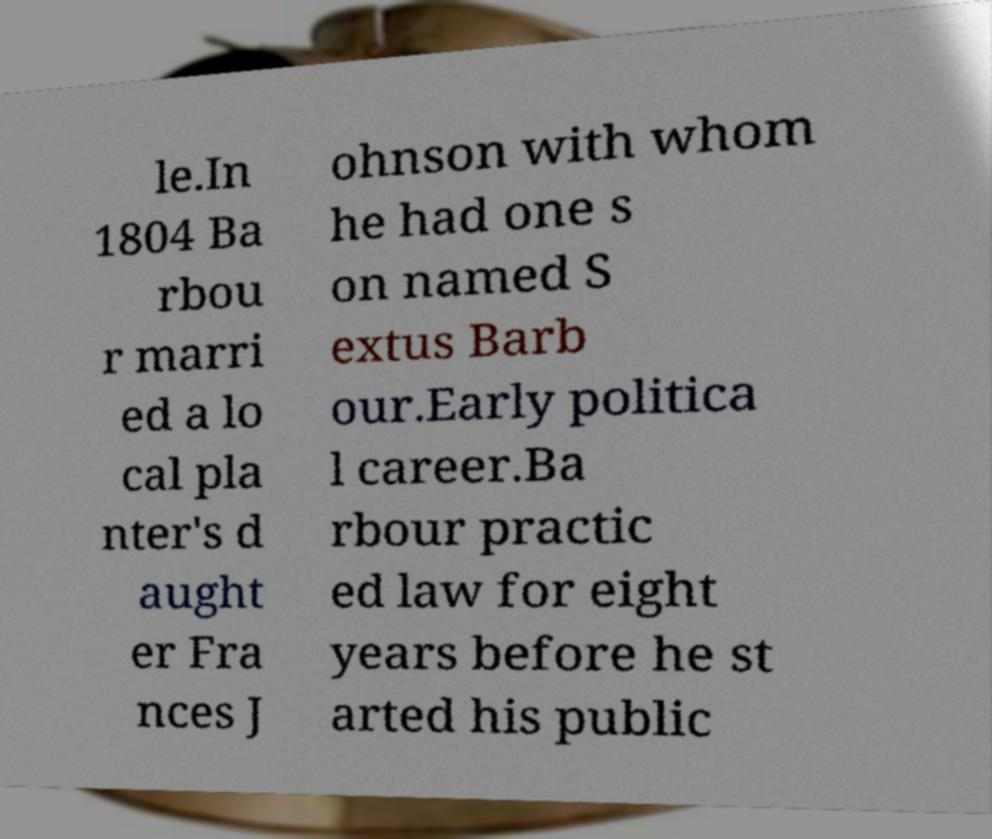Please identify and transcribe the text found in this image. le.In 1804 Ba rbou r marri ed a lo cal pla nter's d aught er Fra nces J ohnson with whom he had one s on named S extus Barb our.Early politica l career.Ba rbour practic ed law for eight years before he st arted his public 